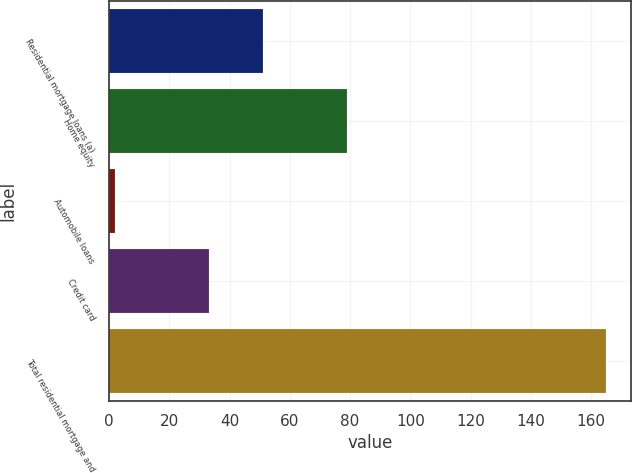<chart> <loc_0><loc_0><loc_500><loc_500><bar_chart><fcel>Residential mortgage loans (a)<fcel>Home equity<fcel>Automobile loans<fcel>Credit card<fcel>Total residential mortgage and<nl><fcel>51<fcel>79<fcel>2<fcel>33<fcel>165<nl></chart> 